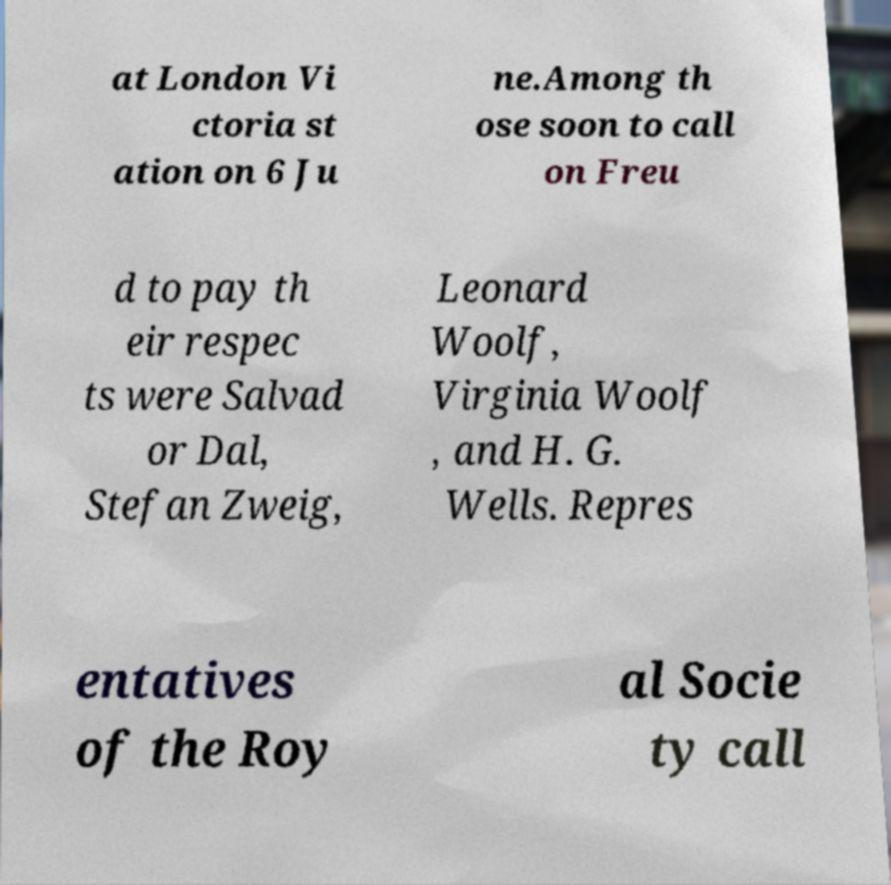Could you extract and type out the text from this image? at London Vi ctoria st ation on 6 Ju ne.Among th ose soon to call on Freu d to pay th eir respec ts were Salvad or Dal, Stefan Zweig, Leonard Woolf, Virginia Woolf , and H. G. Wells. Repres entatives of the Roy al Socie ty call 